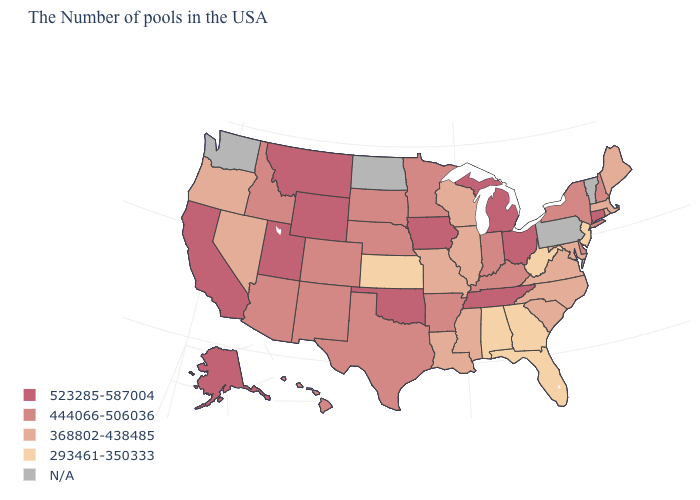Does the first symbol in the legend represent the smallest category?
Keep it brief. No. What is the value of Arkansas?
Be succinct. 444066-506036. How many symbols are there in the legend?
Keep it brief. 5. Name the states that have a value in the range 293461-350333?
Write a very short answer. New Jersey, West Virginia, Florida, Georgia, Alabama, Kansas. Which states have the lowest value in the Northeast?
Write a very short answer. New Jersey. What is the highest value in the USA?
Keep it brief. 523285-587004. What is the highest value in states that border Georgia?
Quick response, please. 523285-587004. Does New Hampshire have the lowest value in the USA?
Write a very short answer. No. What is the value of Texas?
Write a very short answer. 444066-506036. Which states have the highest value in the USA?
Answer briefly. Connecticut, Ohio, Michigan, Tennessee, Iowa, Oklahoma, Wyoming, Utah, Montana, California, Alaska. What is the value of California?
Quick response, please. 523285-587004. Which states have the lowest value in the West?
Be succinct. Nevada, Oregon. Does Montana have the highest value in the USA?
Be succinct. Yes. What is the highest value in states that border Texas?
Give a very brief answer. 523285-587004. Name the states that have a value in the range 444066-506036?
Answer briefly. New Hampshire, New York, Delaware, Kentucky, Indiana, Arkansas, Minnesota, Nebraska, Texas, South Dakota, Colorado, New Mexico, Arizona, Idaho, Hawaii. 